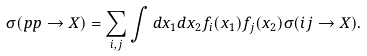<formula> <loc_0><loc_0><loc_500><loc_500>\sigma ( p p \rightarrow X ) = \sum _ { i , j } \int d x _ { 1 } d x _ { 2 } f _ { i } ( x _ { 1 } ) f _ { j } ( x _ { 2 } ) \sigma ( i j \rightarrow X ) .</formula> 